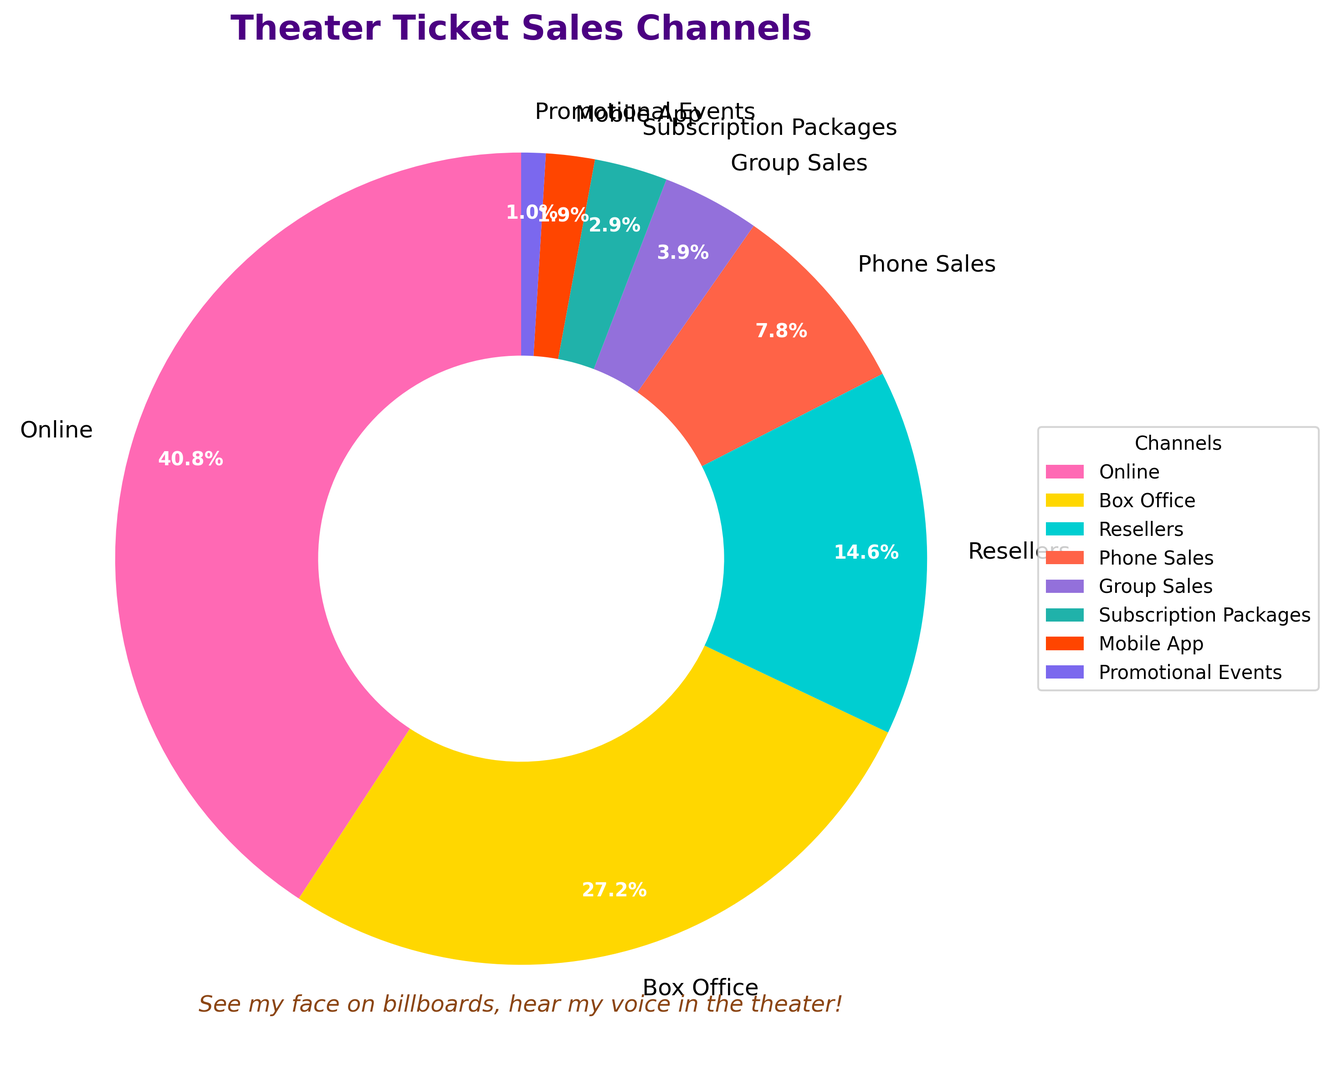What percentage of theater tickets were sold online? Look at the labeled segment for "Online" in the pie chart, which shows the percentage of tickets sold through online channels.
Answer: 42% What is the total percentage of tickets sold through traditional methods (Box Office, Phone Sales, and Group Sales)? Sum the percentages of tickets sold through Box Office (28%), Phone Sales (8%), and Group Sales (4%). 28% + 8% + 4% = 40%
Answer: 40% Which channel sold the least number of tickets? Identify the segment in the pie chart with the smallest percentage. The "Promotional Events" channel has the smallest percentage at 1%.
Answer: Promotional Events Compare the percentage of tickets sold through Online and Box Office. Which one is higher and by how much? The Online channel sold 42% and the Box Office sold 28%. 42% is more than 28%, and the difference is 42% - 28% = 14%.
Answer: Online, by 14% What is the combined percentage of tickets sold through Resellers and Subscription Packages? Sum the percentages of tickets sold through Resellers (15%) and Subscription Packages (3%). 15% + 3% = 18%
Answer: 18% What proportion of sales combined is made up by Mobile App and Promotional Events? Add the percentages for Mobile App (2%) and Promotional Events (1%). 2% + 1% = 3%
Answer: 3% Which sales channel has the second-highest percentage of ticket sales? Identify the segment with the highest percentage (Online) and then find the segment with the next highest percentage, which is "Box Office" at 28%.
Answer: Box Office How much greater is the percentage of Online sales compared to the combined percentage of Mobile App and Promotional Events? Calculate the combined percentage of Mobile App and Promotional Events: 2% + 1% = 3%. Then, subtract this from the percentage of Online sales: 42% - 3% = 39%.
Answer: 39% Identify the channel with a percentage of sales that is less than 5% but does not have the smallest percentage. The Group Sales channel has 4%, which is less than 5% but more than the smallest percentage (1% for Promotional Events).
Answer: Group Sales How do the sales through Resellers compare to sales through Box Office, in terms of greater than, less than, or equal to? The percentage of sales through Resellers (15%) is less than Box Office sales (28%).
Answer: Less than 